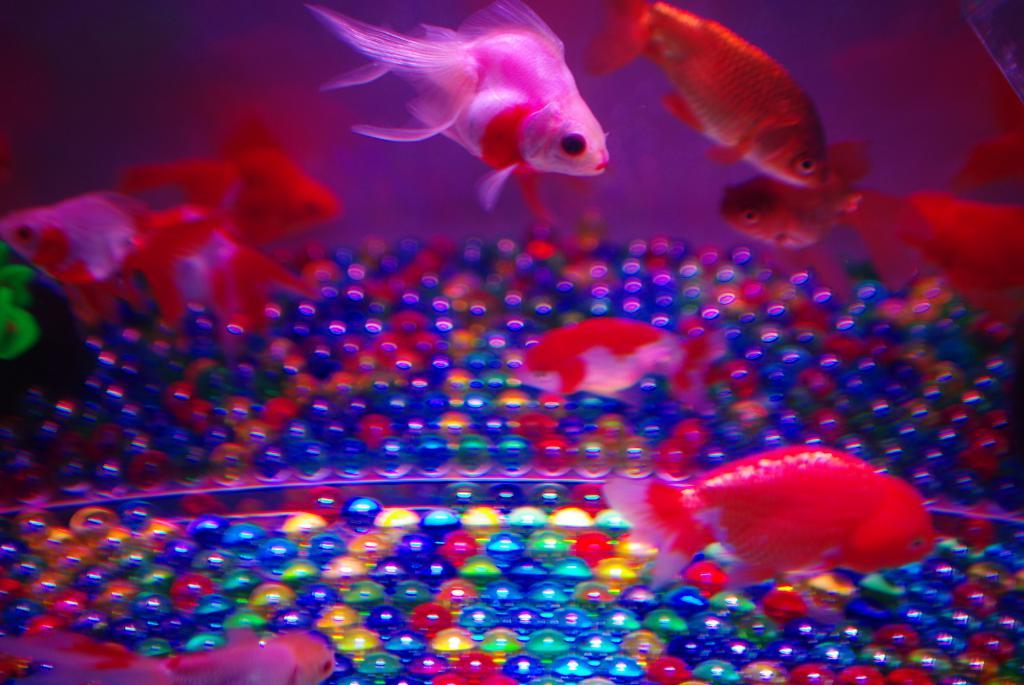What is present in the water in the image? There are fishes in the water in the image. What can be seen in the background of the image? There are colorful balls in the background of the image. How many icicles can be seen hanging from the fishes in the image? There are no icicles present in the image; it features fishes in the water and colorful balls in the background. What type of bird is perched on the colorful balls in the image? There are no birds, including robins, present in the image. 